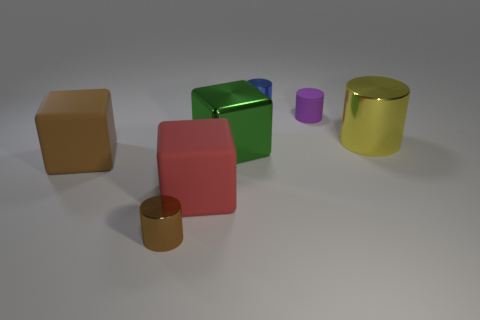Add 1 big red blocks. How many objects exist? 8 Subtract all brown cubes. How many cubes are left? 2 Subtract 2 cylinders. How many cylinders are left? 2 Subtract all large yellow cylinders. How many cylinders are left? 3 Subtract all cylinders. How many objects are left? 3 Subtract all cyan cylinders. Subtract all gray balls. How many cylinders are left? 4 Subtract all green cubes. How many green cylinders are left? 0 Subtract all brown things. Subtract all red blocks. How many objects are left? 4 Add 4 large brown rubber blocks. How many large brown rubber blocks are left? 5 Add 3 small yellow matte cubes. How many small yellow matte cubes exist? 3 